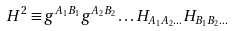<formula> <loc_0><loc_0><loc_500><loc_500>H ^ { 2 } \equiv g ^ { A _ { 1 } B _ { 1 } } g ^ { A _ { 2 } B _ { 2 } } \dots H _ { A _ { 1 } A _ { 2 } \dots } H _ { B _ { 1 } B _ { 2 } \dots }</formula> 